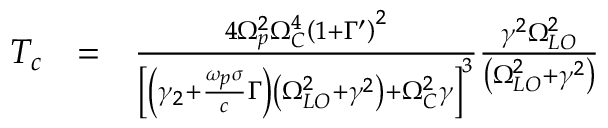Convert formula to latex. <formula><loc_0><loc_0><loc_500><loc_500>\begin{array} { r l r } { T _ { c } } & { = } & { \frac { 4 \Omega _ { p } ^ { 2 } \Omega _ { C } ^ { 4 } \left ( 1 + \Gamma ^ { \prime } \right ) ^ { 2 } } { \left [ \left ( \gamma _ { 2 } + \frac { \omega _ { p } \sigma } { c } \Gamma \right ) \left ( \Omega _ { L O } ^ { 2 } + \gamma ^ { 2 } \right ) + \Omega _ { C } ^ { 2 } \gamma \right ] ^ { 3 } } \frac { \gamma ^ { 2 } \Omega _ { L O } ^ { 2 } } { \left ( \Omega _ { L O } ^ { 2 } + \gamma ^ { 2 } \right ) } } \end{array}</formula> 